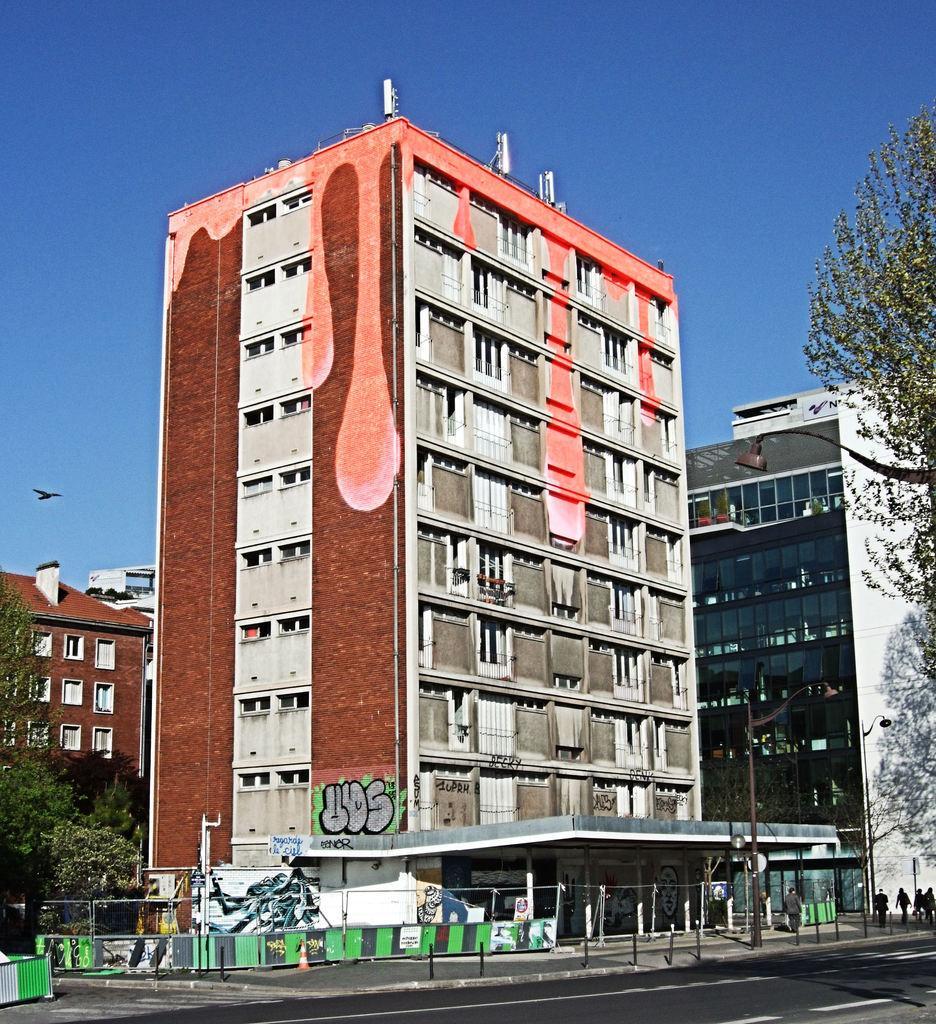In one or two sentences, can you explain what this image depicts? In the foreground of this picture, there is a road, poles and a building. There are trees on either side of the image. In the background, there is a building and a bird in the air, and the sky. 